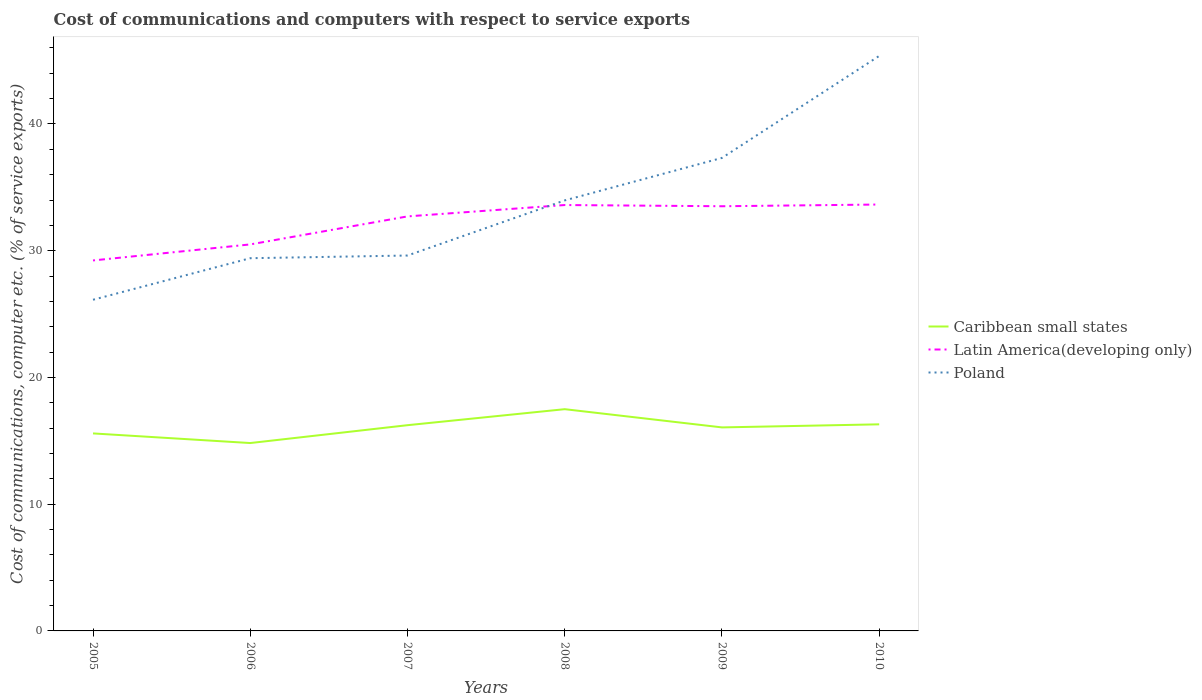Is the number of lines equal to the number of legend labels?
Your answer should be compact. Yes. Across all years, what is the maximum cost of communications and computers in Caribbean small states?
Offer a terse response. 14.82. In which year was the cost of communications and computers in Latin America(developing only) maximum?
Your answer should be very brief. 2005. What is the total cost of communications and computers in Latin America(developing only) in the graph?
Ensure brevity in your answer.  -0.94. What is the difference between the highest and the second highest cost of communications and computers in Latin America(developing only)?
Provide a succinct answer. 4.41. Is the cost of communications and computers in Latin America(developing only) strictly greater than the cost of communications and computers in Caribbean small states over the years?
Offer a terse response. No. How many lines are there?
Provide a succinct answer. 3. Does the graph contain any zero values?
Offer a very short reply. No. Does the graph contain grids?
Your response must be concise. No. How are the legend labels stacked?
Offer a terse response. Vertical. What is the title of the graph?
Offer a terse response. Cost of communications and computers with respect to service exports. Does "Peru" appear as one of the legend labels in the graph?
Your response must be concise. No. What is the label or title of the Y-axis?
Give a very brief answer. Cost of communications, computer etc. (% of service exports). What is the Cost of communications, computer etc. (% of service exports) of Caribbean small states in 2005?
Your answer should be very brief. 15.58. What is the Cost of communications, computer etc. (% of service exports) of Latin America(developing only) in 2005?
Give a very brief answer. 29.23. What is the Cost of communications, computer etc. (% of service exports) of Poland in 2005?
Provide a succinct answer. 26.13. What is the Cost of communications, computer etc. (% of service exports) in Caribbean small states in 2006?
Your answer should be very brief. 14.82. What is the Cost of communications, computer etc. (% of service exports) of Latin America(developing only) in 2006?
Offer a terse response. 30.5. What is the Cost of communications, computer etc. (% of service exports) in Poland in 2006?
Your response must be concise. 29.41. What is the Cost of communications, computer etc. (% of service exports) in Caribbean small states in 2007?
Provide a succinct answer. 16.23. What is the Cost of communications, computer etc. (% of service exports) of Latin America(developing only) in 2007?
Give a very brief answer. 32.71. What is the Cost of communications, computer etc. (% of service exports) of Poland in 2007?
Keep it short and to the point. 29.62. What is the Cost of communications, computer etc. (% of service exports) of Caribbean small states in 2008?
Provide a short and direct response. 17.5. What is the Cost of communications, computer etc. (% of service exports) in Latin America(developing only) in 2008?
Your answer should be very brief. 33.61. What is the Cost of communications, computer etc. (% of service exports) in Poland in 2008?
Offer a terse response. 33.97. What is the Cost of communications, computer etc. (% of service exports) of Caribbean small states in 2009?
Keep it short and to the point. 16.06. What is the Cost of communications, computer etc. (% of service exports) of Latin America(developing only) in 2009?
Your answer should be very brief. 33.51. What is the Cost of communications, computer etc. (% of service exports) of Poland in 2009?
Give a very brief answer. 37.32. What is the Cost of communications, computer etc. (% of service exports) in Caribbean small states in 2010?
Provide a succinct answer. 16.3. What is the Cost of communications, computer etc. (% of service exports) in Latin America(developing only) in 2010?
Keep it short and to the point. 33.65. What is the Cost of communications, computer etc. (% of service exports) in Poland in 2010?
Your answer should be compact. 45.37. Across all years, what is the maximum Cost of communications, computer etc. (% of service exports) in Caribbean small states?
Your answer should be compact. 17.5. Across all years, what is the maximum Cost of communications, computer etc. (% of service exports) of Latin America(developing only)?
Provide a short and direct response. 33.65. Across all years, what is the maximum Cost of communications, computer etc. (% of service exports) in Poland?
Offer a terse response. 45.37. Across all years, what is the minimum Cost of communications, computer etc. (% of service exports) of Caribbean small states?
Your answer should be compact. 14.82. Across all years, what is the minimum Cost of communications, computer etc. (% of service exports) in Latin America(developing only)?
Offer a very short reply. 29.23. Across all years, what is the minimum Cost of communications, computer etc. (% of service exports) in Poland?
Offer a terse response. 26.13. What is the total Cost of communications, computer etc. (% of service exports) in Caribbean small states in the graph?
Offer a very short reply. 96.5. What is the total Cost of communications, computer etc. (% of service exports) in Latin America(developing only) in the graph?
Offer a terse response. 193.2. What is the total Cost of communications, computer etc. (% of service exports) in Poland in the graph?
Make the answer very short. 201.83. What is the difference between the Cost of communications, computer etc. (% of service exports) in Caribbean small states in 2005 and that in 2006?
Offer a terse response. 0.76. What is the difference between the Cost of communications, computer etc. (% of service exports) in Latin America(developing only) in 2005 and that in 2006?
Provide a succinct answer. -1.26. What is the difference between the Cost of communications, computer etc. (% of service exports) in Poland in 2005 and that in 2006?
Make the answer very short. -3.28. What is the difference between the Cost of communications, computer etc. (% of service exports) of Caribbean small states in 2005 and that in 2007?
Offer a terse response. -0.65. What is the difference between the Cost of communications, computer etc. (% of service exports) of Latin America(developing only) in 2005 and that in 2007?
Offer a terse response. -3.48. What is the difference between the Cost of communications, computer etc. (% of service exports) in Poland in 2005 and that in 2007?
Your answer should be compact. -3.49. What is the difference between the Cost of communications, computer etc. (% of service exports) in Caribbean small states in 2005 and that in 2008?
Provide a short and direct response. -1.91. What is the difference between the Cost of communications, computer etc. (% of service exports) of Latin America(developing only) in 2005 and that in 2008?
Ensure brevity in your answer.  -4.37. What is the difference between the Cost of communications, computer etc. (% of service exports) of Poland in 2005 and that in 2008?
Your answer should be very brief. -7.84. What is the difference between the Cost of communications, computer etc. (% of service exports) in Caribbean small states in 2005 and that in 2009?
Your answer should be compact. -0.47. What is the difference between the Cost of communications, computer etc. (% of service exports) of Latin America(developing only) in 2005 and that in 2009?
Your answer should be compact. -4.28. What is the difference between the Cost of communications, computer etc. (% of service exports) in Poland in 2005 and that in 2009?
Provide a succinct answer. -11.19. What is the difference between the Cost of communications, computer etc. (% of service exports) of Caribbean small states in 2005 and that in 2010?
Keep it short and to the point. -0.72. What is the difference between the Cost of communications, computer etc. (% of service exports) in Latin America(developing only) in 2005 and that in 2010?
Offer a terse response. -4.41. What is the difference between the Cost of communications, computer etc. (% of service exports) of Poland in 2005 and that in 2010?
Provide a succinct answer. -19.24. What is the difference between the Cost of communications, computer etc. (% of service exports) of Caribbean small states in 2006 and that in 2007?
Your answer should be very brief. -1.41. What is the difference between the Cost of communications, computer etc. (% of service exports) in Latin America(developing only) in 2006 and that in 2007?
Offer a terse response. -2.21. What is the difference between the Cost of communications, computer etc. (% of service exports) of Poland in 2006 and that in 2007?
Make the answer very short. -0.21. What is the difference between the Cost of communications, computer etc. (% of service exports) in Caribbean small states in 2006 and that in 2008?
Your answer should be very brief. -2.67. What is the difference between the Cost of communications, computer etc. (% of service exports) of Latin America(developing only) in 2006 and that in 2008?
Your response must be concise. -3.11. What is the difference between the Cost of communications, computer etc. (% of service exports) of Poland in 2006 and that in 2008?
Give a very brief answer. -4.56. What is the difference between the Cost of communications, computer etc. (% of service exports) of Caribbean small states in 2006 and that in 2009?
Your response must be concise. -1.23. What is the difference between the Cost of communications, computer etc. (% of service exports) in Latin America(developing only) in 2006 and that in 2009?
Make the answer very short. -3.01. What is the difference between the Cost of communications, computer etc. (% of service exports) of Poland in 2006 and that in 2009?
Your answer should be very brief. -7.91. What is the difference between the Cost of communications, computer etc. (% of service exports) of Caribbean small states in 2006 and that in 2010?
Offer a very short reply. -1.48. What is the difference between the Cost of communications, computer etc. (% of service exports) of Latin America(developing only) in 2006 and that in 2010?
Offer a very short reply. -3.15. What is the difference between the Cost of communications, computer etc. (% of service exports) of Poland in 2006 and that in 2010?
Your answer should be very brief. -15.96. What is the difference between the Cost of communications, computer etc. (% of service exports) in Caribbean small states in 2007 and that in 2008?
Your answer should be very brief. -1.26. What is the difference between the Cost of communications, computer etc. (% of service exports) of Latin America(developing only) in 2007 and that in 2008?
Ensure brevity in your answer.  -0.9. What is the difference between the Cost of communications, computer etc. (% of service exports) of Poland in 2007 and that in 2008?
Offer a terse response. -4.35. What is the difference between the Cost of communications, computer etc. (% of service exports) in Caribbean small states in 2007 and that in 2009?
Your response must be concise. 0.17. What is the difference between the Cost of communications, computer etc. (% of service exports) in Latin America(developing only) in 2007 and that in 2009?
Keep it short and to the point. -0.8. What is the difference between the Cost of communications, computer etc. (% of service exports) of Poland in 2007 and that in 2009?
Ensure brevity in your answer.  -7.7. What is the difference between the Cost of communications, computer etc. (% of service exports) of Caribbean small states in 2007 and that in 2010?
Make the answer very short. -0.07. What is the difference between the Cost of communications, computer etc. (% of service exports) of Latin America(developing only) in 2007 and that in 2010?
Keep it short and to the point. -0.94. What is the difference between the Cost of communications, computer etc. (% of service exports) of Poland in 2007 and that in 2010?
Provide a short and direct response. -15.75. What is the difference between the Cost of communications, computer etc. (% of service exports) in Caribbean small states in 2008 and that in 2009?
Provide a short and direct response. 1.44. What is the difference between the Cost of communications, computer etc. (% of service exports) of Latin America(developing only) in 2008 and that in 2009?
Keep it short and to the point. 0.1. What is the difference between the Cost of communications, computer etc. (% of service exports) of Poland in 2008 and that in 2009?
Your answer should be compact. -3.35. What is the difference between the Cost of communications, computer etc. (% of service exports) of Caribbean small states in 2008 and that in 2010?
Provide a succinct answer. 1.19. What is the difference between the Cost of communications, computer etc. (% of service exports) of Latin America(developing only) in 2008 and that in 2010?
Your answer should be very brief. -0.04. What is the difference between the Cost of communications, computer etc. (% of service exports) of Poland in 2008 and that in 2010?
Offer a terse response. -11.4. What is the difference between the Cost of communications, computer etc. (% of service exports) in Caribbean small states in 2009 and that in 2010?
Make the answer very short. -0.24. What is the difference between the Cost of communications, computer etc. (% of service exports) in Latin America(developing only) in 2009 and that in 2010?
Give a very brief answer. -0.14. What is the difference between the Cost of communications, computer etc. (% of service exports) of Poland in 2009 and that in 2010?
Your answer should be very brief. -8.05. What is the difference between the Cost of communications, computer etc. (% of service exports) in Caribbean small states in 2005 and the Cost of communications, computer etc. (% of service exports) in Latin America(developing only) in 2006?
Provide a succinct answer. -14.91. What is the difference between the Cost of communications, computer etc. (% of service exports) in Caribbean small states in 2005 and the Cost of communications, computer etc. (% of service exports) in Poland in 2006?
Your answer should be compact. -13.83. What is the difference between the Cost of communications, computer etc. (% of service exports) of Latin America(developing only) in 2005 and the Cost of communications, computer etc. (% of service exports) of Poland in 2006?
Your answer should be very brief. -0.18. What is the difference between the Cost of communications, computer etc. (% of service exports) in Caribbean small states in 2005 and the Cost of communications, computer etc. (% of service exports) in Latin America(developing only) in 2007?
Offer a terse response. -17.12. What is the difference between the Cost of communications, computer etc. (% of service exports) of Caribbean small states in 2005 and the Cost of communications, computer etc. (% of service exports) of Poland in 2007?
Provide a succinct answer. -14.04. What is the difference between the Cost of communications, computer etc. (% of service exports) of Latin America(developing only) in 2005 and the Cost of communications, computer etc. (% of service exports) of Poland in 2007?
Your answer should be very brief. -0.39. What is the difference between the Cost of communications, computer etc. (% of service exports) of Caribbean small states in 2005 and the Cost of communications, computer etc. (% of service exports) of Latin America(developing only) in 2008?
Make the answer very short. -18.02. What is the difference between the Cost of communications, computer etc. (% of service exports) in Caribbean small states in 2005 and the Cost of communications, computer etc. (% of service exports) in Poland in 2008?
Offer a very short reply. -18.39. What is the difference between the Cost of communications, computer etc. (% of service exports) of Latin America(developing only) in 2005 and the Cost of communications, computer etc. (% of service exports) of Poland in 2008?
Your answer should be very brief. -4.74. What is the difference between the Cost of communications, computer etc. (% of service exports) in Caribbean small states in 2005 and the Cost of communications, computer etc. (% of service exports) in Latin America(developing only) in 2009?
Offer a terse response. -17.92. What is the difference between the Cost of communications, computer etc. (% of service exports) of Caribbean small states in 2005 and the Cost of communications, computer etc. (% of service exports) of Poland in 2009?
Offer a terse response. -21.74. What is the difference between the Cost of communications, computer etc. (% of service exports) in Latin America(developing only) in 2005 and the Cost of communications, computer etc. (% of service exports) in Poland in 2009?
Your answer should be compact. -8.09. What is the difference between the Cost of communications, computer etc. (% of service exports) of Caribbean small states in 2005 and the Cost of communications, computer etc. (% of service exports) of Latin America(developing only) in 2010?
Your answer should be very brief. -18.06. What is the difference between the Cost of communications, computer etc. (% of service exports) of Caribbean small states in 2005 and the Cost of communications, computer etc. (% of service exports) of Poland in 2010?
Offer a very short reply. -29.79. What is the difference between the Cost of communications, computer etc. (% of service exports) of Latin America(developing only) in 2005 and the Cost of communications, computer etc. (% of service exports) of Poland in 2010?
Make the answer very short. -16.14. What is the difference between the Cost of communications, computer etc. (% of service exports) in Caribbean small states in 2006 and the Cost of communications, computer etc. (% of service exports) in Latin America(developing only) in 2007?
Your response must be concise. -17.88. What is the difference between the Cost of communications, computer etc. (% of service exports) in Caribbean small states in 2006 and the Cost of communications, computer etc. (% of service exports) in Poland in 2007?
Offer a very short reply. -14.8. What is the difference between the Cost of communications, computer etc. (% of service exports) in Latin America(developing only) in 2006 and the Cost of communications, computer etc. (% of service exports) in Poland in 2007?
Keep it short and to the point. 0.88. What is the difference between the Cost of communications, computer etc. (% of service exports) in Caribbean small states in 2006 and the Cost of communications, computer etc. (% of service exports) in Latin America(developing only) in 2008?
Offer a very short reply. -18.78. What is the difference between the Cost of communications, computer etc. (% of service exports) in Caribbean small states in 2006 and the Cost of communications, computer etc. (% of service exports) in Poland in 2008?
Offer a terse response. -19.15. What is the difference between the Cost of communications, computer etc. (% of service exports) of Latin America(developing only) in 2006 and the Cost of communications, computer etc. (% of service exports) of Poland in 2008?
Your answer should be very brief. -3.47. What is the difference between the Cost of communications, computer etc. (% of service exports) in Caribbean small states in 2006 and the Cost of communications, computer etc. (% of service exports) in Latin America(developing only) in 2009?
Your answer should be very brief. -18.68. What is the difference between the Cost of communications, computer etc. (% of service exports) in Caribbean small states in 2006 and the Cost of communications, computer etc. (% of service exports) in Poland in 2009?
Provide a succinct answer. -22.5. What is the difference between the Cost of communications, computer etc. (% of service exports) of Latin America(developing only) in 2006 and the Cost of communications, computer etc. (% of service exports) of Poland in 2009?
Keep it short and to the point. -6.83. What is the difference between the Cost of communications, computer etc. (% of service exports) of Caribbean small states in 2006 and the Cost of communications, computer etc. (% of service exports) of Latin America(developing only) in 2010?
Provide a short and direct response. -18.82. What is the difference between the Cost of communications, computer etc. (% of service exports) in Caribbean small states in 2006 and the Cost of communications, computer etc. (% of service exports) in Poland in 2010?
Your response must be concise. -30.55. What is the difference between the Cost of communications, computer etc. (% of service exports) of Latin America(developing only) in 2006 and the Cost of communications, computer etc. (% of service exports) of Poland in 2010?
Ensure brevity in your answer.  -14.87. What is the difference between the Cost of communications, computer etc. (% of service exports) in Caribbean small states in 2007 and the Cost of communications, computer etc. (% of service exports) in Latin America(developing only) in 2008?
Your answer should be very brief. -17.37. What is the difference between the Cost of communications, computer etc. (% of service exports) in Caribbean small states in 2007 and the Cost of communications, computer etc. (% of service exports) in Poland in 2008?
Provide a short and direct response. -17.74. What is the difference between the Cost of communications, computer etc. (% of service exports) in Latin America(developing only) in 2007 and the Cost of communications, computer etc. (% of service exports) in Poland in 2008?
Keep it short and to the point. -1.26. What is the difference between the Cost of communications, computer etc. (% of service exports) in Caribbean small states in 2007 and the Cost of communications, computer etc. (% of service exports) in Latin America(developing only) in 2009?
Your response must be concise. -17.28. What is the difference between the Cost of communications, computer etc. (% of service exports) of Caribbean small states in 2007 and the Cost of communications, computer etc. (% of service exports) of Poland in 2009?
Give a very brief answer. -21.09. What is the difference between the Cost of communications, computer etc. (% of service exports) in Latin America(developing only) in 2007 and the Cost of communications, computer etc. (% of service exports) in Poland in 2009?
Provide a succinct answer. -4.62. What is the difference between the Cost of communications, computer etc. (% of service exports) of Caribbean small states in 2007 and the Cost of communications, computer etc. (% of service exports) of Latin America(developing only) in 2010?
Make the answer very short. -17.41. What is the difference between the Cost of communications, computer etc. (% of service exports) in Caribbean small states in 2007 and the Cost of communications, computer etc. (% of service exports) in Poland in 2010?
Give a very brief answer. -29.14. What is the difference between the Cost of communications, computer etc. (% of service exports) in Latin America(developing only) in 2007 and the Cost of communications, computer etc. (% of service exports) in Poland in 2010?
Give a very brief answer. -12.66. What is the difference between the Cost of communications, computer etc. (% of service exports) in Caribbean small states in 2008 and the Cost of communications, computer etc. (% of service exports) in Latin America(developing only) in 2009?
Ensure brevity in your answer.  -16.01. What is the difference between the Cost of communications, computer etc. (% of service exports) of Caribbean small states in 2008 and the Cost of communications, computer etc. (% of service exports) of Poland in 2009?
Your response must be concise. -19.83. What is the difference between the Cost of communications, computer etc. (% of service exports) in Latin America(developing only) in 2008 and the Cost of communications, computer etc. (% of service exports) in Poland in 2009?
Keep it short and to the point. -3.72. What is the difference between the Cost of communications, computer etc. (% of service exports) in Caribbean small states in 2008 and the Cost of communications, computer etc. (% of service exports) in Latin America(developing only) in 2010?
Make the answer very short. -16.15. What is the difference between the Cost of communications, computer etc. (% of service exports) of Caribbean small states in 2008 and the Cost of communications, computer etc. (% of service exports) of Poland in 2010?
Your answer should be very brief. -27.87. What is the difference between the Cost of communications, computer etc. (% of service exports) in Latin America(developing only) in 2008 and the Cost of communications, computer etc. (% of service exports) in Poland in 2010?
Make the answer very short. -11.76. What is the difference between the Cost of communications, computer etc. (% of service exports) in Caribbean small states in 2009 and the Cost of communications, computer etc. (% of service exports) in Latin America(developing only) in 2010?
Make the answer very short. -17.59. What is the difference between the Cost of communications, computer etc. (% of service exports) in Caribbean small states in 2009 and the Cost of communications, computer etc. (% of service exports) in Poland in 2010?
Offer a very short reply. -29.31. What is the difference between the Cost of communications, computer etc. (% of service exports) of Latin America(developing only) in 2009 and the Cost of communications, computer etc. (% of service exports) of Poland in 2010?
Provide a succinct answer. -11.86. What is the average Cost of communications, computer etc. (% of service exports) in Caribbean small states per year?
Make the answer very short. 16.08. What is the average Cost of communications, computer etc. (% of service exports) in Latin America(developing only) per year?
Ensure brevity in your answer.  32.2. What is the average Cost of communications, computer etc. (% of service exports) in Poland per year?
Offer a very short reply. 33.64. In the year 2005, what is the difference between the Cost of communications, computer etc. (% of service exports) in Caribbean small states and Cost of communications, computer etc. (% of service exports) in Latin America(developing only)?
Provide a succinct answer. -13.65. In the year 2005, what is the difference between the Cost of communications, computer etc. (% of service exports) of Caribbean small states and Cost of communications, computer etc. (% of service exports) of Poland?
Provide a succinct answer. -10.55. In the year 2005, what is the difference between the Cost of communications, computer etc. (% of service exports) of Latin America(developing only) and Cost of communications, computer etc. (% of service exports) of Poland?
Provide a succinct answer. 3.1. In the year 2006, what is the difference between the Cost of communications, computer etc. (% of service exports) of Caribbean small states and Cost of communications, computer etc. (% of service exports) of Latin America(developing only)?
Your answer should be compact. -15.67. In the year 2006, what is the difference between the Cost of communications, computer etc. (% of service exports) in Caribbean small states and Cost of communications, computer etc. (% of service exports) in Poland?
Keep it short and to the point. -14.59. In the year 2006, what is the difference between the Cost of communications, computer etc. (% of service exports) in Latin America(developing only) and Cost of communications, computer etc. (% of service exports) in Poland?
Your answer should be compact. 1.09. In the year 2007, what is the difference between the Cost of communications, computer etc. (% of service exports) in Caribbean small states and Cost of communications, computer etc. (% of service exports) in Latin America(developing only)?
Your answer should be compact. -16.47. In the year 2007, what is the difference between the Cost of communications, computer etc. (% of service exports) in Caribbean small states and Cost of communications, computer etc. (% of service exports) in Poland?
Keep it short and to the point. -13.39. In the year 2007, what is the difference between the Cost of communications, computer etc. (% of service exports) in Latin America(developing only) and Cost of communications, computer etc. (% of service exports) in Poland?
Ensure brevity in your answer.  3.09. In the year 2008, what is the difference between the Cost of communications, computer etc. (% of service exports) in Caribbean small states and Cost of communications, computer etc. (% of service exports) in Latin America(developing only)?
Provide a short and direct response. -16.11. In the year 2008, what is the difference between the Cost of communications, computer etc. (% of service exports) in Caribbean small states and Cost of communications, computer etc. (% of service exports) in Poland?
Your response must be concise. -16.47. In the year 2008, what is the difference between the Cost of communications, computer etc. (% of service exports) of Latin America(developing only) and Cost of communications, computer etc. (% of service exports) of Poland?
Keep it short and to the point. -0.37. In the year 2009, what is the difference between the Cost of communications, computer etc. (% of service exports) in Caribbean small states and Cost of communications, computer etc. (% of service exports) in Latin America(developing only)?
Keep it short and to the point. -17.45. In the year 2009, what is the difference between the Cost of communications, computer etc. (% of service exports) of Caribbean small states and Cost of communications, computer etc. (% of service exports) of Poland?
Your answer should be very brief. -21.26. In the year 2009, what is the difference between the Cost of communications, computer etc. (% of service exports) of Latin America(developing only) and Cost of communications, computer etc. (% of service exports) of Poland?
Offer a terse response. -3.81. In the year 2010, what is the difference between the Cost of communications, computer etc. (% of service exports) of Caribbean small states and Cost of communications, computer etc. (% of service exports) of Latin America(developing only)?
Give a very brief answer. -17.34. In the year 2010, what is the difference between the Cost of communications, computer etc. (% of service exports) in Caribbean small states and Cost of communications, computer etc. (% of service exports) in Poland?
Provide a succinct answer. -29.07. In the year 2010, what is the difference between the Cost of communications, computer etc. (% of service exports) in Latin America(developing only) and Cost of communications, computer etc. (% of service exports) in Poland?
Provide a short and direct response. -11.72. What is the ratio of the Cost of communications, computer etc. (% of service exports) in Caribbean small states in 2005 to that in 2006?
Your answer should be very brief. 1.05. What is the ratio of the Cost of communications, computer etc. (% of service exports) of Latin America(developing only) in 2005 to that in 2006?
Your answer should be very brief. 0.96. What is the ratio of the Cost of communications, computer etc. (% of service exports) in Poland in 2005 to that in 2006?
Keep it short and to the point. 0.89. What is the ratio of the Cost of communications, computer etc. (% of service exports) in Caribbean small states in 2005 to that in 2007?
Provide a short and direct response. 0.96. What is the ratio of the Cost of communications, computer etc. (% of service exports) of Latin America(developing only) in 2005 to that in 2007?
Your response must be concise. 0.89. What is the ratio of the Cost of communications, computer etc. (% of service exports) of Poland in 2005 to that in 2007?
Offer a very short reply. 0.88. What is the ratio of the Cost of communications, computer etc. (% of service exports) in Caribbean small states in 2005 to that in 2008?
Keep it short and to the point. 0.89. What is the ratio of the Cost of communications, computer etc. (% of service exports) of Latin America(developing only) in 2005 to that in 2008?
Provide a short and direct response. 0.87. What is the ratio of the Cost of communications, computer etc. (% of service exports) in Poland in 2005 to that in 2008?
Your response must be concise. 0.77. What is the ratio of the Cost of communications, computer etc. (% of service exports) of Caribbean small states in 2005 to that in 2009?
Offer a very short reply. 0.97. What is the ratio of the Cost of communications, computer etc. (% of service exports) in Latin America(developing only) in 2005 to that in 2009?
Offer a terse response. 0.87. What is the ratio of the Cost of communications, computer etc. (% of service exports) of Poland in 2005 to that in 2009?
Make the answer very short. 0.7. What is the ratio of the Cost of communications, computer etc. (% of service exports) of Caribbean small states in 2005 to that in 2010?
Offer a very short reply. 0.96. What is the ratio of the Cost of communications, computer etc. (% of service exports) in Latin America(developing only) in 2005 to that in 2010?
Your answer should be very brief. 0.87. What is the ratio of the Cost of communications, computer etc. (% of service exports) in Poland in 2005 to that in 2010?
Provide a short and direct response. 0.58. What is the ratio of the Cost of communications, computer etc. (% of service exports) in Caribbean small states in 2006 to that in 2007?
Provide a succinct answer. 0.91. What is the ratio of the Cost of communications, computer etc. (% of service exports) in Latin America(developing only) in 2006 to that in 2007?
Give a very brief answer. 0.93. What is the ratio of the Cost of communications, computer etc. (% of service exports) of Caribbean small states in 2006 to that in 2008?
Provide a short and direct response. 0.85. What is the ratio of the Cost of communications, computer etc. (% of service exports) of Latin America(developing only) in 2006 to that in 2008?
Your answer should be compact. 0.91. What is the ratio of the Cost of communications, computer etc. (% of service exports) in Poland in 2006 to that in 2008?
Offer a terse response. 0.87. What is the ratio of the Cost of communications, computer etc. (% of service exports) in Latin America(developing only) in 2006 to that in 2009?
Your answer should be compact. 0.91. What is the ratio of the Cost of communications, computer etc. (% of service exports) in Poland in 2006 to that in 2009?
Provide a succinct answer. 0.79. What is the ratio of the Cost of communications, computer etc. (% of service exports) in Caribbean small states in 2006 to that in 2010?
Provide a succinct answer. 0.91. What is the ratio of the Cost of communications, computer etc. (% of service exports) in Latin America(developing only) in 2006 to that in 2010?
Make the answer very short. 0.91. What is the ratio of the Cost of communications, computer etc. (% of service exports) of Poland in 2006 to that in 2010?
Your response must be concise. 0.65. What is the ratio of the Cost of communications, computer etc. (% of service exports) of Caribbean small states in 2007 to that in 2008?
Ensure brevity in your answer.  0.93. What is the ratio of the Cost of communications, computer etc. (% of service exports) in Latin America(developing only) in 2007 to that in 2008?
Give a very brief answer. 0.97. What is the ratio of the Cost of communications, computer etc. (% of service exports) of Poland in 2007 to that in 2008?
Ensure brevity in your answer.  0.87. What is the ratio of the Cost of communications, computer etc. (% of service exports) of Caribbean small states in 2007 to that in 2009?
Offer a very short reply. 1.01. What is the ratio of the Cost of communications, computer etc. (% of service exports) of Latin America(developing only) in 2007 to that in 2009?
Your response must be concise. 0.98. What is the ratio of the Cost of communications, computer etc. (% of service exports) of Poland in 2007 to that in 2009?
Make the answer very short. 0.79. What is the ratio of the Cost of communications, computer etc. (% of service exports) of Latin America(developing only) in 2007 to that in 2010?
Offer a very short reply. 0.97. What is the ratio of the Cost of communications, computer etc. (% of service exports) of Poland in 2007 to that in 2010?
Provide a succinct answer. 0.65. What is the ratio of the Cost of communications, computer etc. (% of service exports) in Caribbean small states in 2008 to that in 2009?
Your response must be concise. 1.09. What is the ratio of the Cost of communications, computer etc. (% of service exports) in Poland in 2008 to that in 2009?
Provide a succinct answer. 0.91. What is the ratio of the Cost of communications, computer etc. (% of service exports) in Caribbean small states in 2008 to that in 2010?
Your answer should be compact. 1.07. What is the ratio of the Cost of communications, computer etc. (% of service exports) in Poland in 2008 to that in 2010?
Your response must be concise. 0.75. What is the ratio of the Cost of communications, computer etc. (% of service exports) in Caribbean small states in 2009 to that in 2010?
Your answer should be very brief. 0.99. What is the ratio of the Cost of communications, computer etc. (% of service exports) of Latin America(developing only) in 2009 to that in 2010?
Provide a succinct answer. 1. What is the ratio of the Cost of communications, computer etc. (% of service exports) of Poland in 2009 to that in 2010?
Provide a succinct answer. 0.82. What is the difference between the highest and the second highest Cost of communications, computer etc. (% of service exports) of Caribbean small states?
Provide a short and direct response. 1.19. What is the difference between the highest and the second highest Cost of communications, computer etc. (% of service exports) of Latin America(developing only)?
Provide a short and direct response. 0.04. What is the difference between the highest and the second highest Cost of communications, computer etc. (% of service exports) in Poland?
Keep it short and to the point. 8.05. What is the difference between the highest and the lowest Cost of communications, computer etc. (% of service exports) in Caribbean small states?
Your response must be concise. 2.67. What is the difference between the highest and the lowest Cost of communications, computer etc. (% of service exports) in Latin America(developing only)?
Your answer should be compact. 4.41. What is the difference between the highest and the lowest Cost of communications, computer etc. (% of service exports) of Poland?
Make the answer very short. 19.24. 